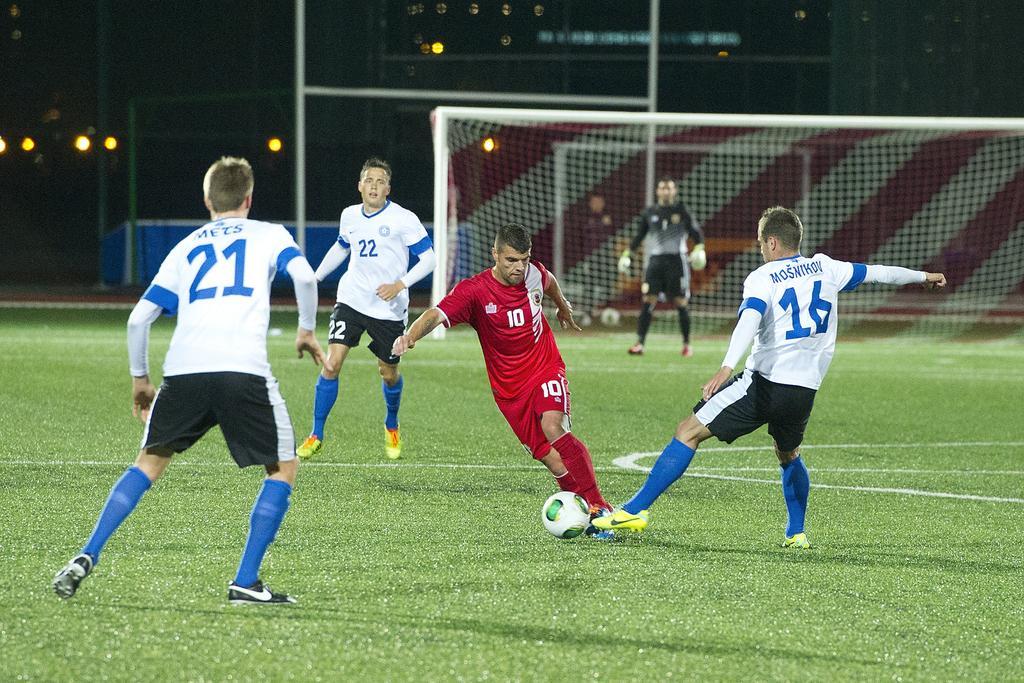How would you summarize this image in a sentence or two? in this picture there are four players who are playing a football in the ground. There is a referee at the background. There is a net at the background and there is a light at the background. 